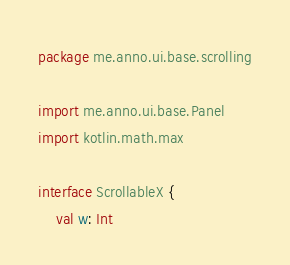<code> <loc_0><loc_0><loc_500><loc_500><_Kotlin_>package me.anno.ui.base.scrolling

import me.anno.ui.base.Panel
import kotlin.math.max

interface ScrollableX {
    val w: Int</code> 